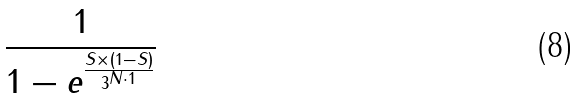Convert formula to latex. <formula><loc_0><loc_0><loc_500><loc_500>\frac { 1 } { 1 - e ^ { \frac { S \times ( 1 - S ) } { 3 ^ { N \cdot 1 } } } }</formula> 